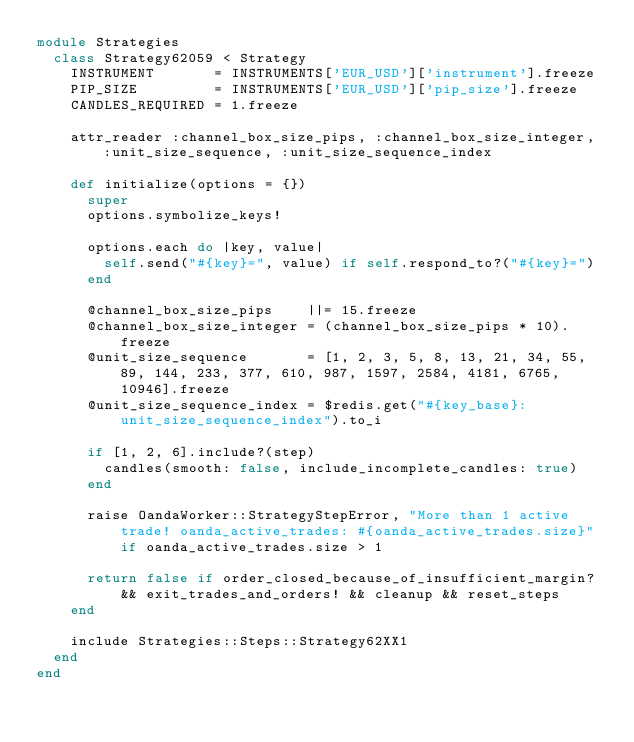<code> <loc_0><loc_0><loc_500><loc_500><_Ruby_>module Strategies
  class Strategy62059 < Strategy
    INSTRUMENT       = INSTRUMENTS['EUR_USD']['instrument'].freeze
    PIP_SIZE         = INSTRUMENTS['EUR_USD']['pip_size'].freeze
    CANDLES_REQUIRED = 1.freeze

    attr_reader :channel_box_size_pips, :channel_box_size_integer, :unit_size_sequence, :unit_size_sequence_index

    def initialize(options = {})
      super
      options.symbolize_keys!

      options.each do |key, value|
        self.send("#{key}=", value) if self.respond_to?("#{key}=")
      end

      @channel_box_size_pips    ||= 15.freeze
      @channel_box_size_integer = (channel_box_size_pips * 10).freeze
      @unit_size_sequence       = [1, 2, 3, 5, 8, 13, 21, 34, 55, 89, 144, 233, 377, 610, 987, 1597, 2584, 4181, 6765, 10946].freeze
      @unit_size_sequence_index = $redis.get("#{key_base}:unit_size_sequence_index").to_i

      if [1, 2, 6].include?(step)
        candles(smooth: false, include_incomplete_candles: true)
      end

      raise OandaWorker::StrategyStepError, "More than 1 active trade! oanda_active_trades: #{oanda_active_trades.size}" if oanda_active_trades.size > 1

      return false if order_closed_because_of_insufficient_margin? && exit_trades_and_orders! && cleanup && reset_steps
    end

    include Strategies::Steps::Strategy62XX1
  end
end
</code> 